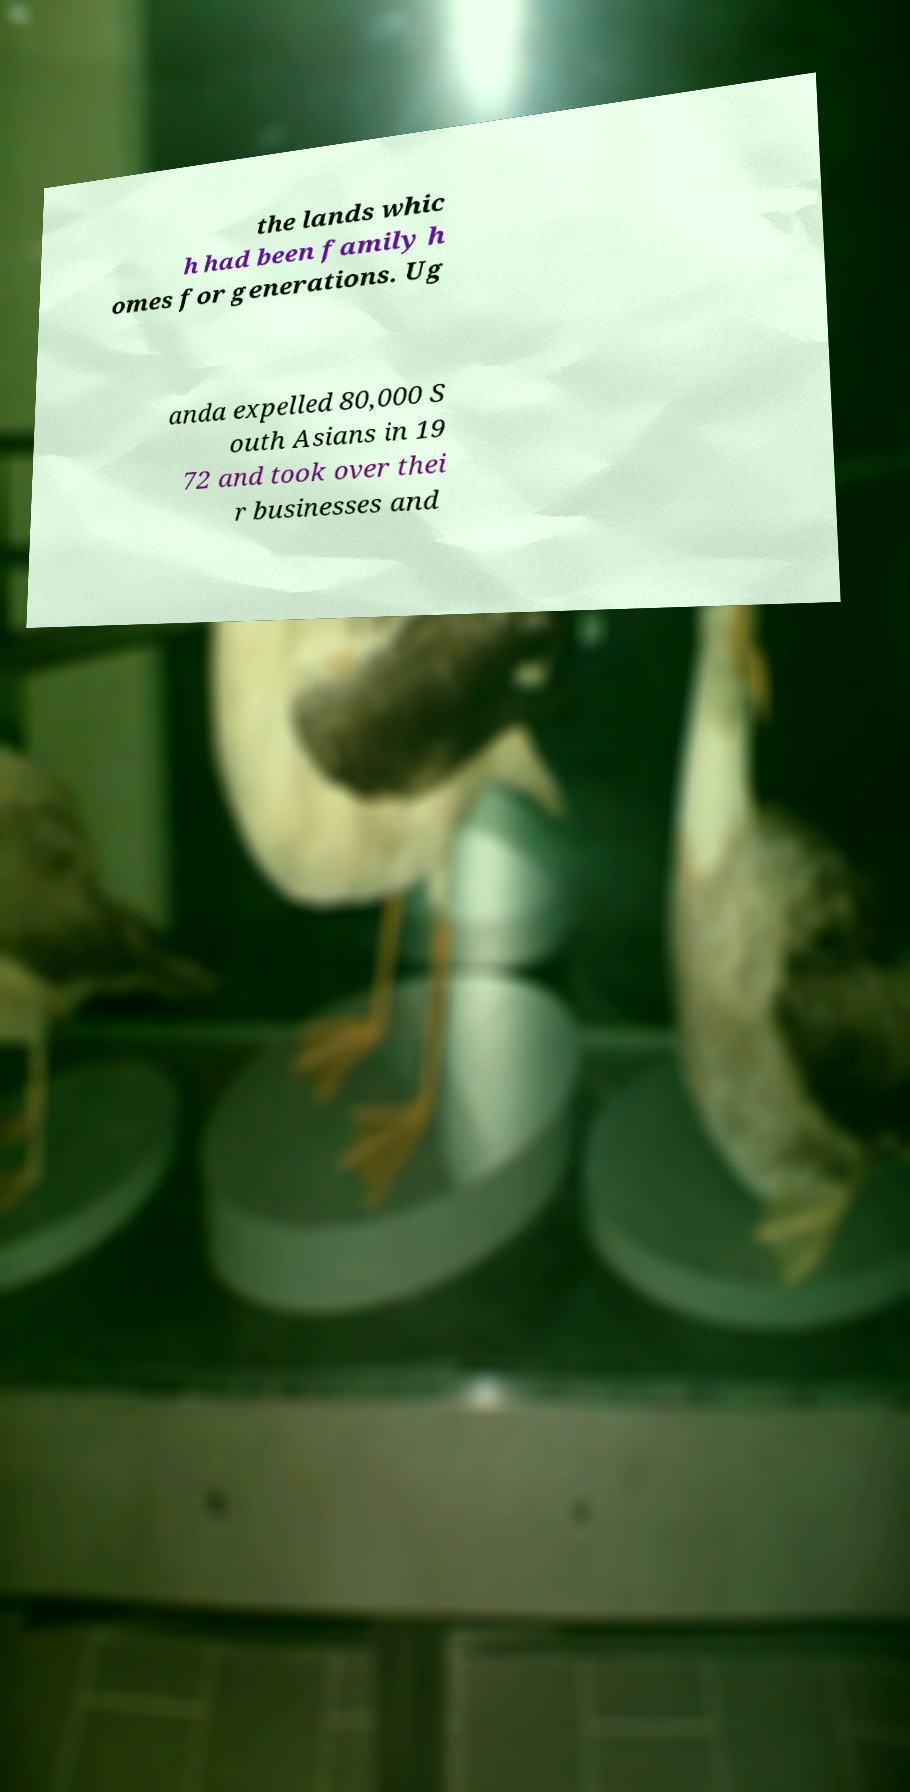What messages or text are displayed in this image? I need them in a readable, typed format. the lands whic h had been family h omes for generations. Ug anda expelled 80,000 S outh Asians in 19 72 and took over thei r businesses and 